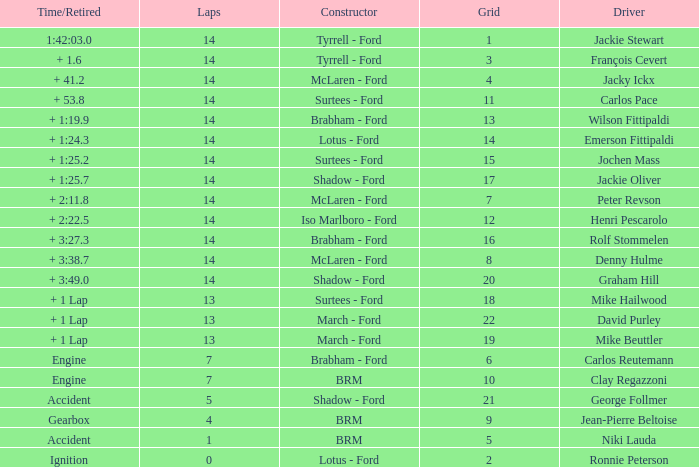What is the low lap total for henri pescarolo with a grad larger than 6? 14.0. 